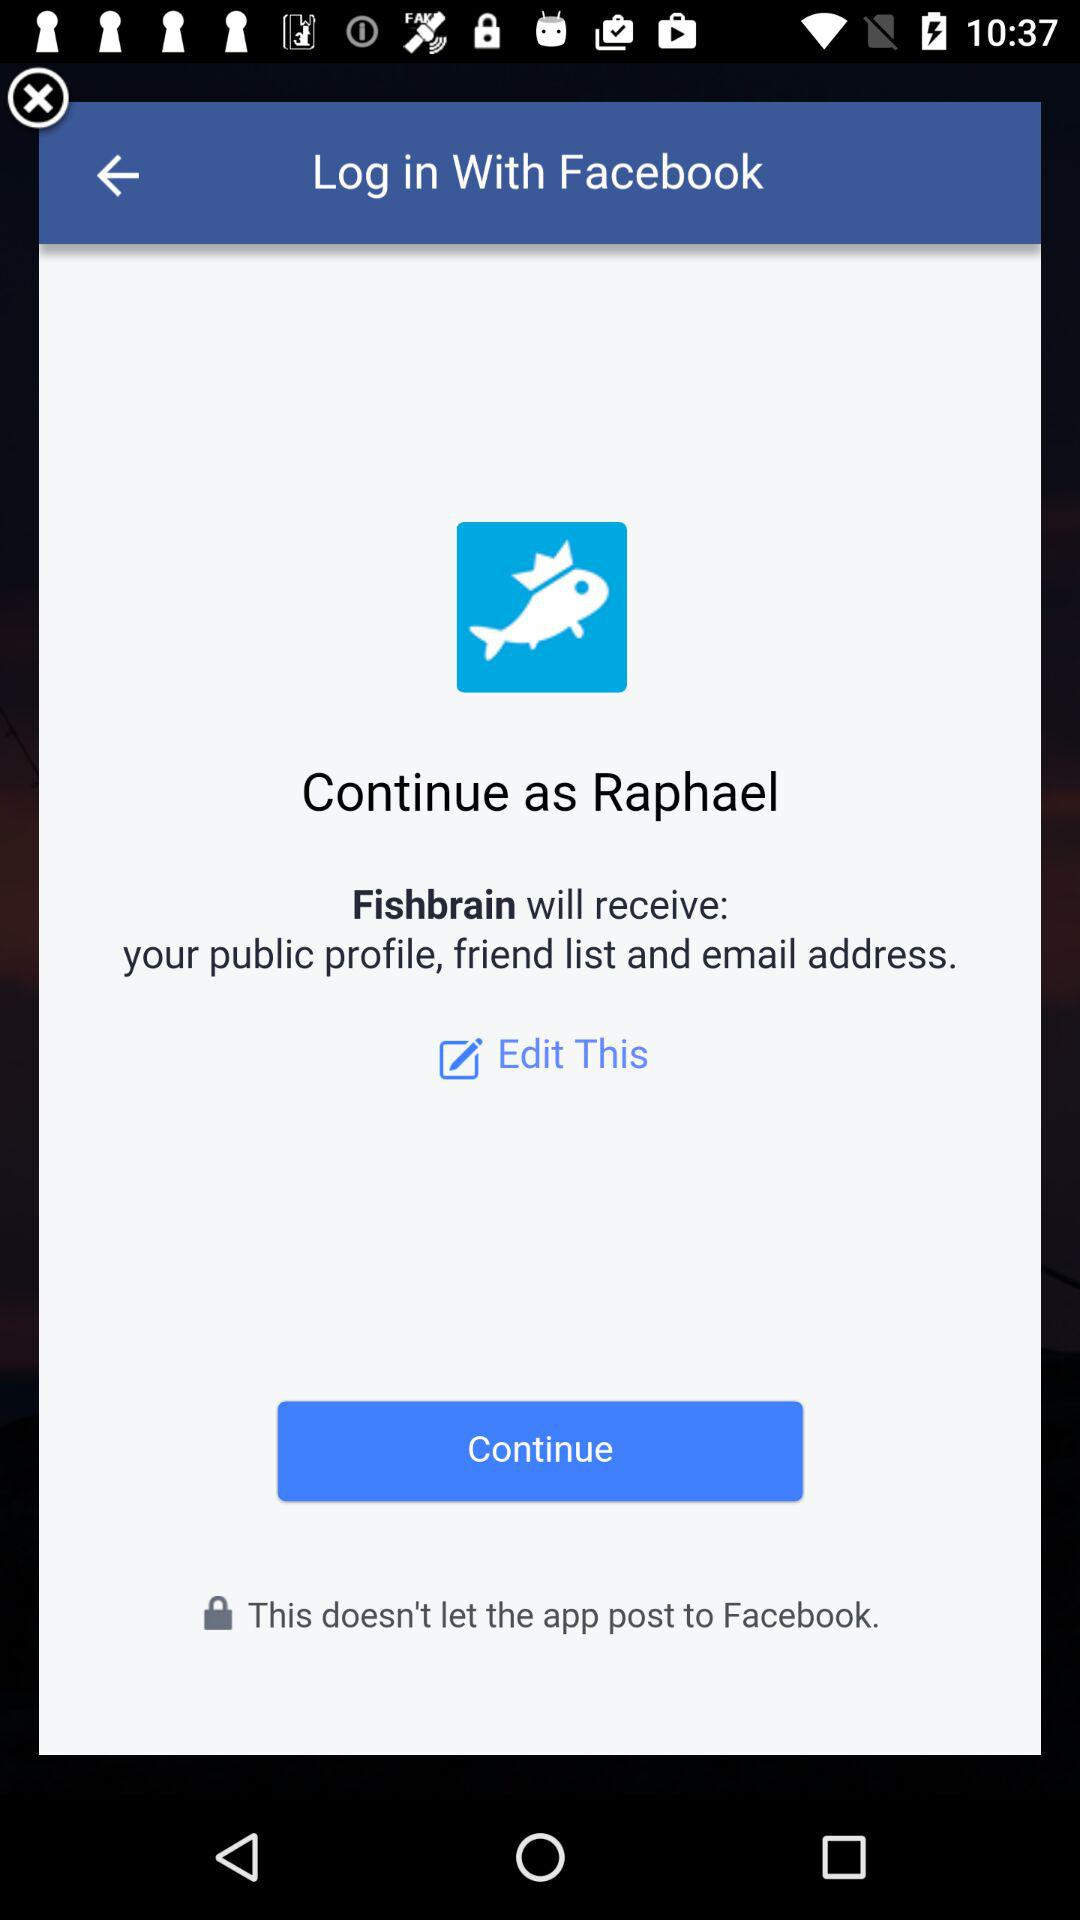What application will receive your public profile, friend list and email address? The application is "Fishbrain". 